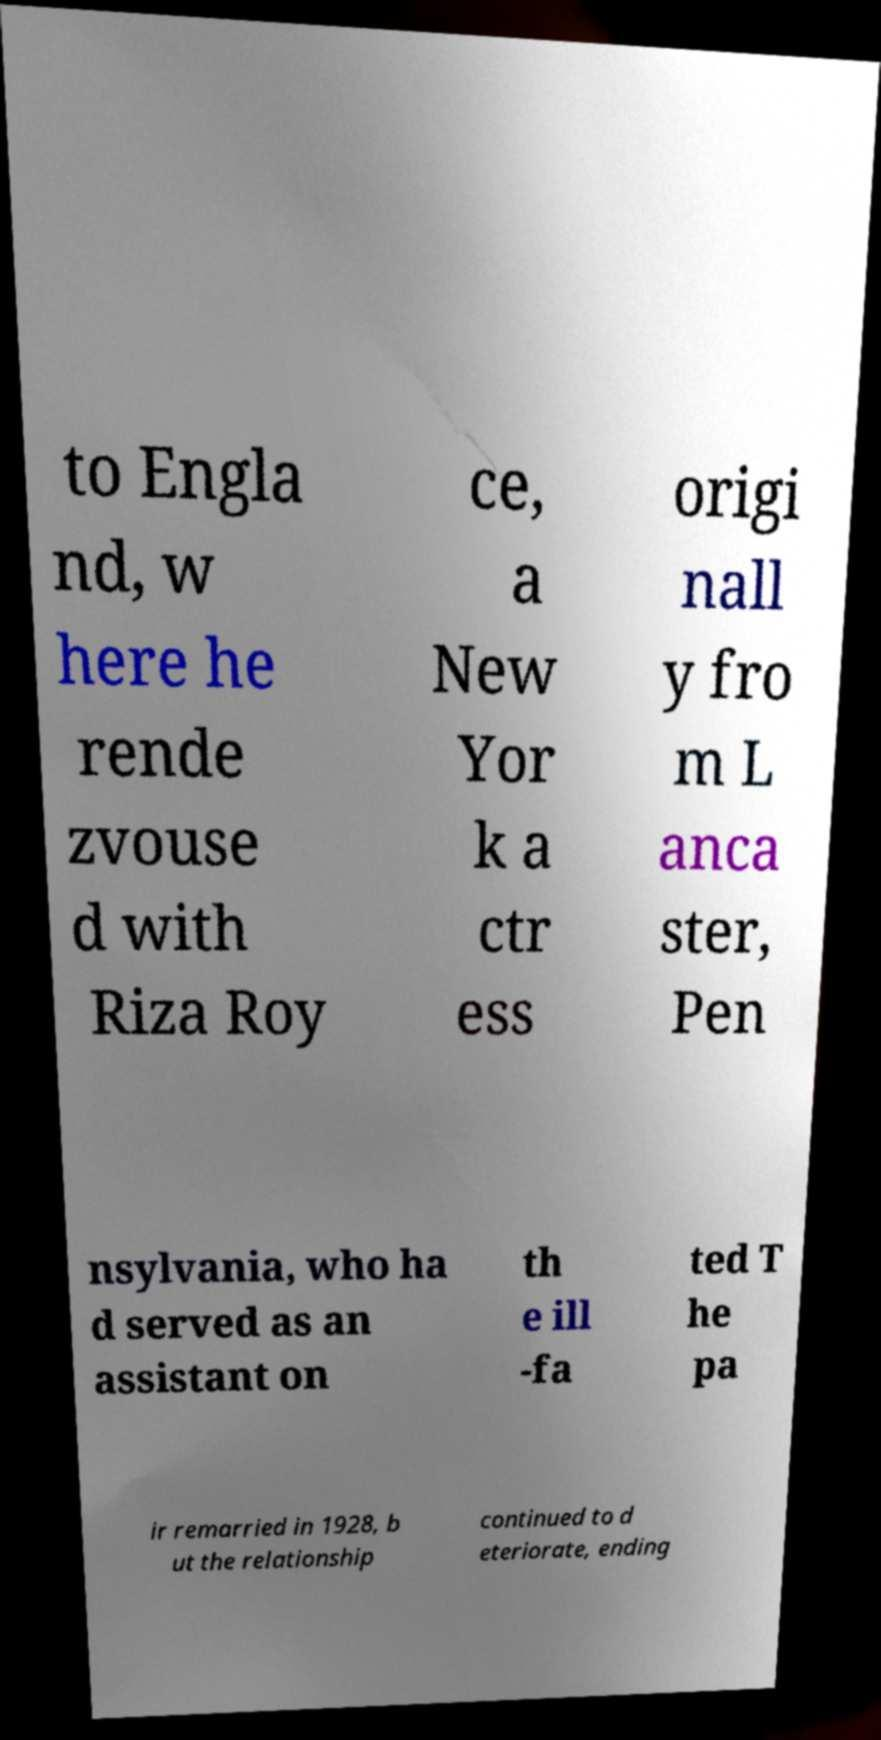Could you extract and type out the text from this image? to Engla nd, w here he rende zvouse d with Riza Roy ce, a New Yor k a ctr ess origi nall y fro m L anca ster, Pen nsylvania, who ha d served as an assistant on th e ill -fa ted T he pa ir remarried in 1928, b ut the relationship continued to d eteriorate, ending 